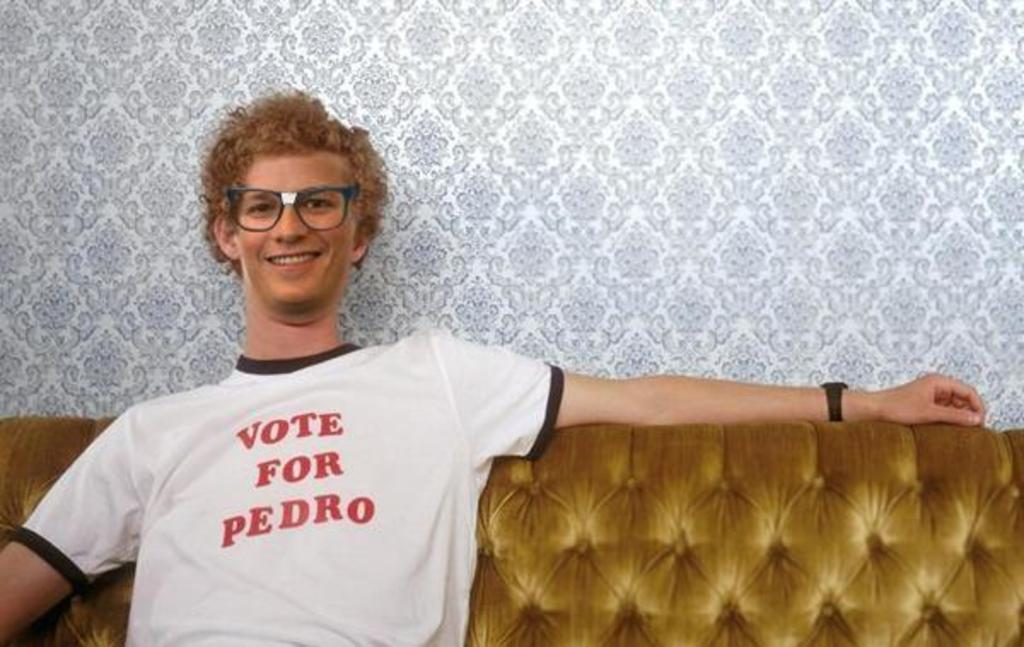What is the main subject of the image? There is a person in the image. What is the person wearing? The person is wearing a white t-shirt. What is the person doing in the image? The person is sitting on a sofa and smiling. What can be seen in the background of the image? There is a floral design on the wall in the background. What type of punishment is being discussed by the committee in the image? There is no committee or discussion of punishment present in the image; it features a person sitting on a sofa and smiling. What kind of patch is visible on the person's t-shirt in the image? There is no patch visible on the person's t-shirt in the image; it is a plain white t-shirt. 